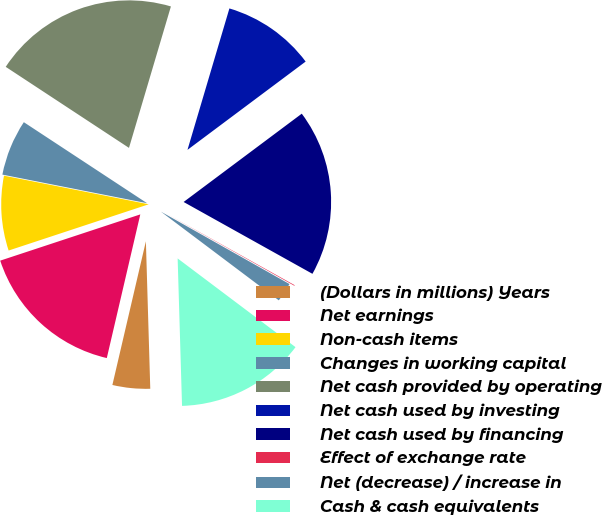<chart> <loc_0><loc_0><loc_500><loc_500><pie_chart><fcel>(Dollars in millions) Years<fcel>Net earnings<fcel>Non-cash items<fcel>Changes in working capital<fcel>Net cash provided by operating<fcel>Net cash used by investing<fcel>Net cash used by financing<fcel>Effect of exchange rate<fcel>Net (decrease) / increase in<fcel>Cash & cash equivalents<nl><fcel>4.12%<fcel>16.28%<fcel>8.18%<fcel>6.15%<fcel>20.33%<fcel>10.2%<fcel>18.31%<fcel>0.07%<fcel>2.1%<fcel>14.26%<nl></chart> 